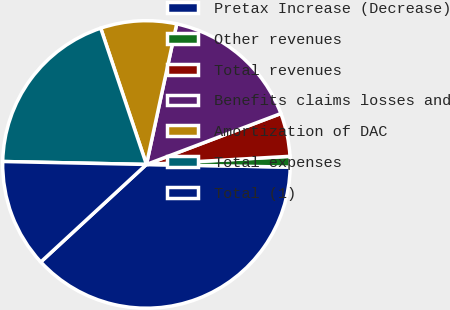Convert chart to OTSL. <chart><loc_0><loc_0><loc_500><loc_500><pie_chart><fcel>Pretax Increase (Decrease)<fcel>Other revenues<fcel>Total revenues<fcel>Benefits claims losses and<fcel>Amortization of DAC<fcel>Total expenses<fcel>Total (1)<nl><fcel>37.84%<fcel>1.2%<fcel>4.86%<fcel>15.86%<fcel>8.53%<fcel>19.52%<fcel>12.19%<nl></chart> 